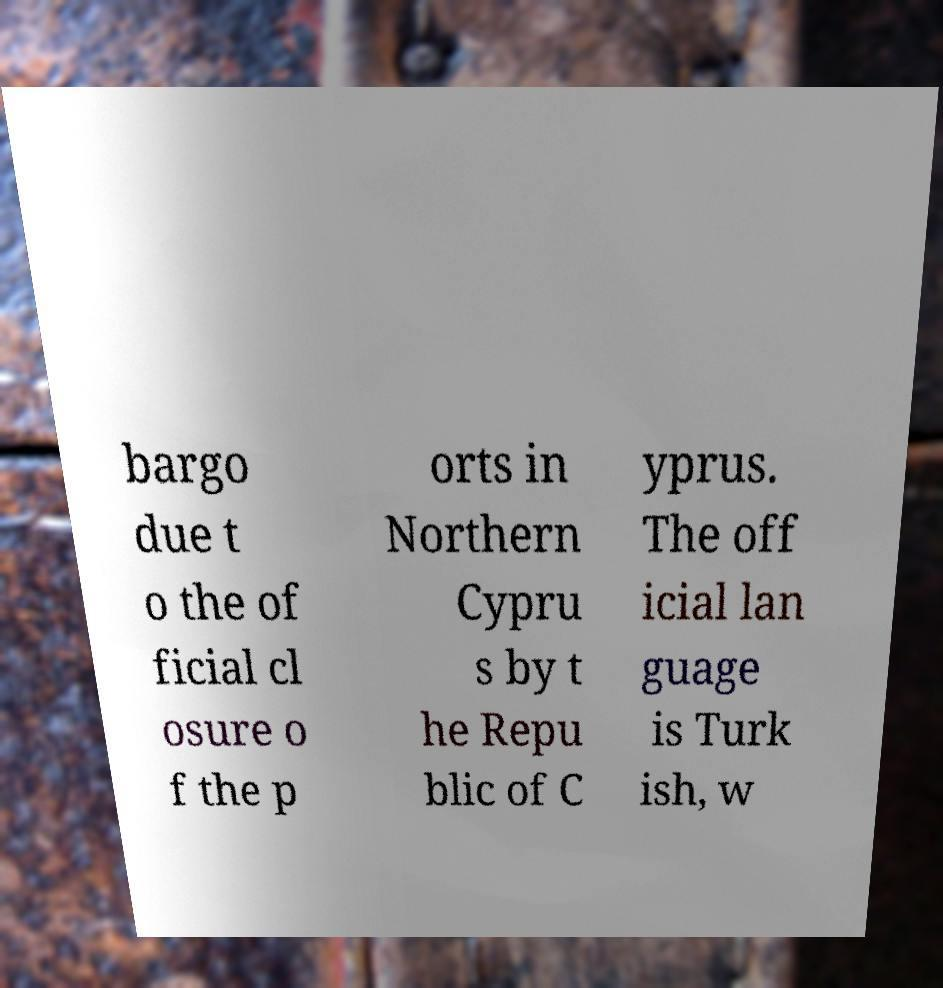Can you read and provide the text displayed in the image?This photo seems to have some interesting text. Can you extract and type it out for me? bargo due t o the of ficial cl osure o f the p orts in Northern Cypru s by t he Repu blic of C yprus. The off icial lan guage is Turk ish, w 